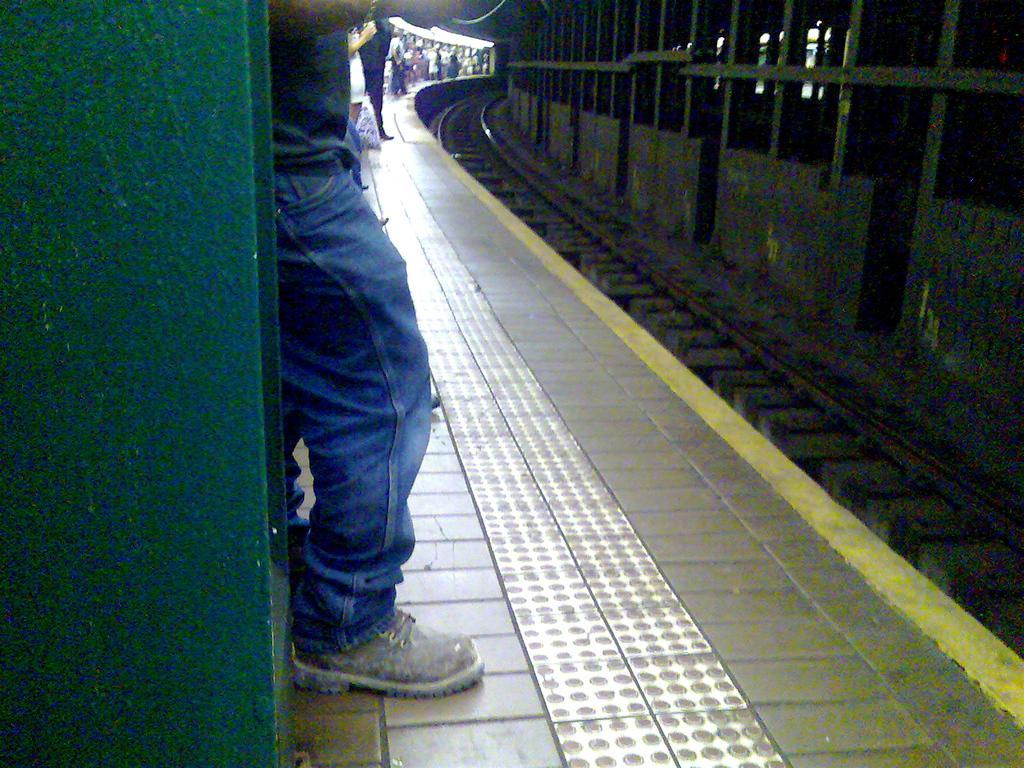Please provide a concise description of this image. In this image I can see the track. To the left I can see few people are standing on the platform and wearing the different color dresses. 